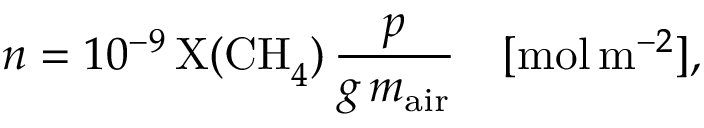<formula> <loc_0><loc_0><loc_500><loc_500>n = 1 0 ^ { - 9 } \, X ( C H _ { 4 } ) \, \frac { p } { g \, m _ { a i r } } \quad [ m o l \, m ^ { - 2 } ] ,</formula> 